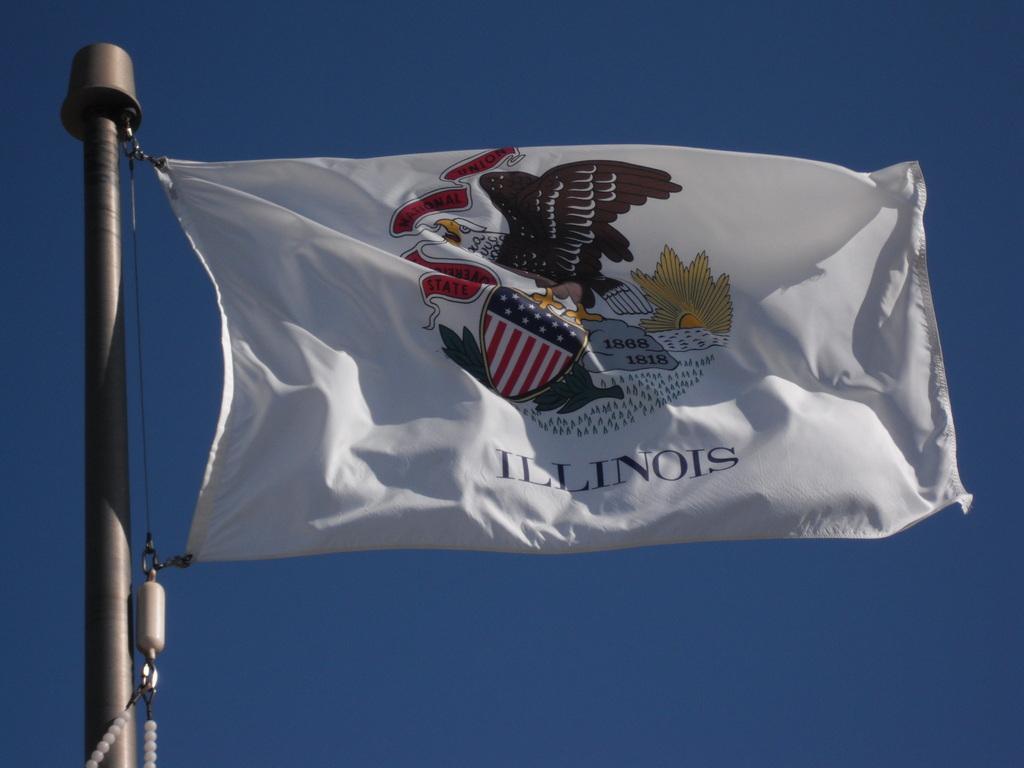Can you describe this image briefly? There is white color flag, which is attached to the silver color pole, which is having a thread. In the background, there is a blue color sky. 